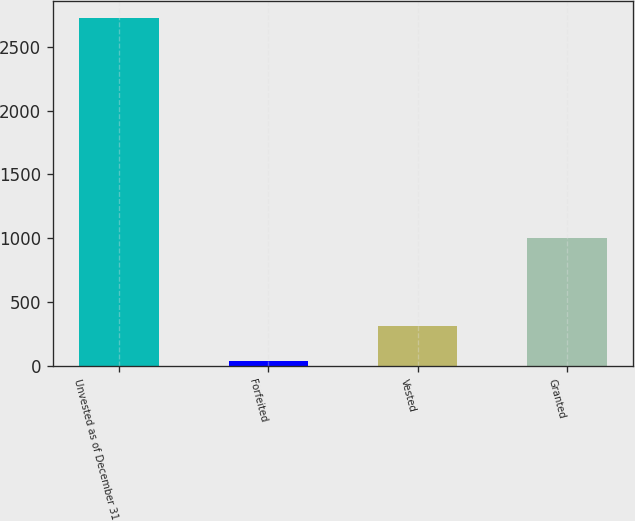Convert chart. <chart><loc_0><loc_0><loc_500><loc_500><bar_chart><fcel>Unvested as of December 31<fcel>Forfeited<fcel>Vested<fcel>Granted<nl><fcel>2722.7<fcel>40<fcel>313<fcel>1002<nl></chart> 